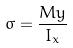<formula> <loc_0><loc_0><loc_500><loc_500>\sigma = \frac { M y } { I _ { x } }</formula> 